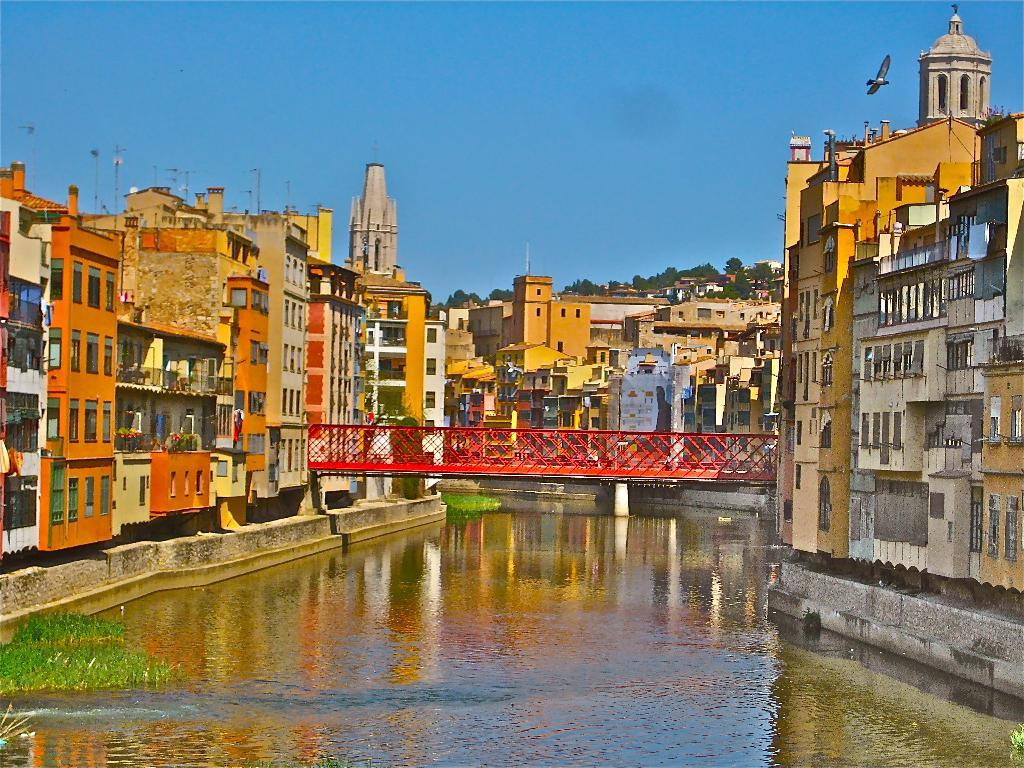What type of structures can be seen in the image? There are buildings in the image. What is floating on the water in the image? There are plants on the water in the image. What are the tall, thin objects in the image? There are poles in the image. What type of vegetation is present in the image? There are trees in the image. What is happening in the sky in the image? There is a bird flying in the sky in the image. What type of natural scenery is visible in the image? Trees are visible in the image. Where is the icicle located in the image? There is no icicle present in the image. How many giants can be seen in the image? There are no giants present in the image. 